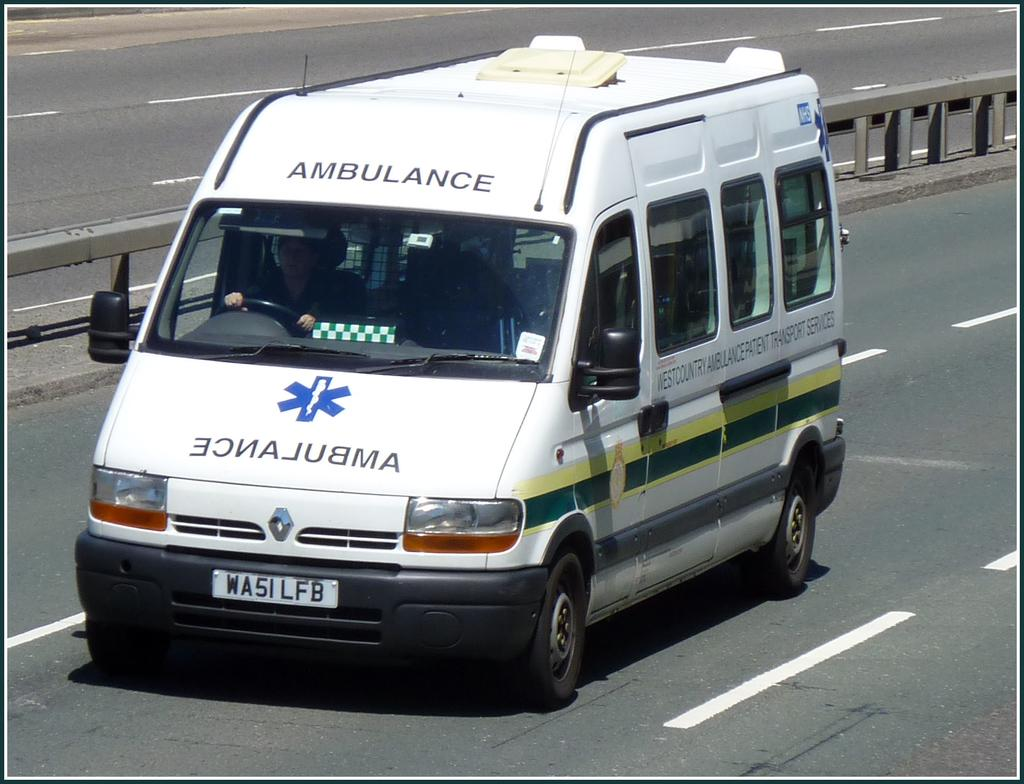What is the main subject of the image? The main subject of the image is an ambulance. Where is the ambulance located? The ambulance is on the road. Is there anyone inside the ambulance? Yes, there is a person sitting in the ambulance. What can be seen in the background of the image? There is a road divider and white lines visible on the road in the background. What type of fan is visible in the image? There is no fan present in the image. Is there a pocket on the person sitting in the ambulance? The image does not provide enough detail to determine if the person sitting in the ambulance has a pocket. 